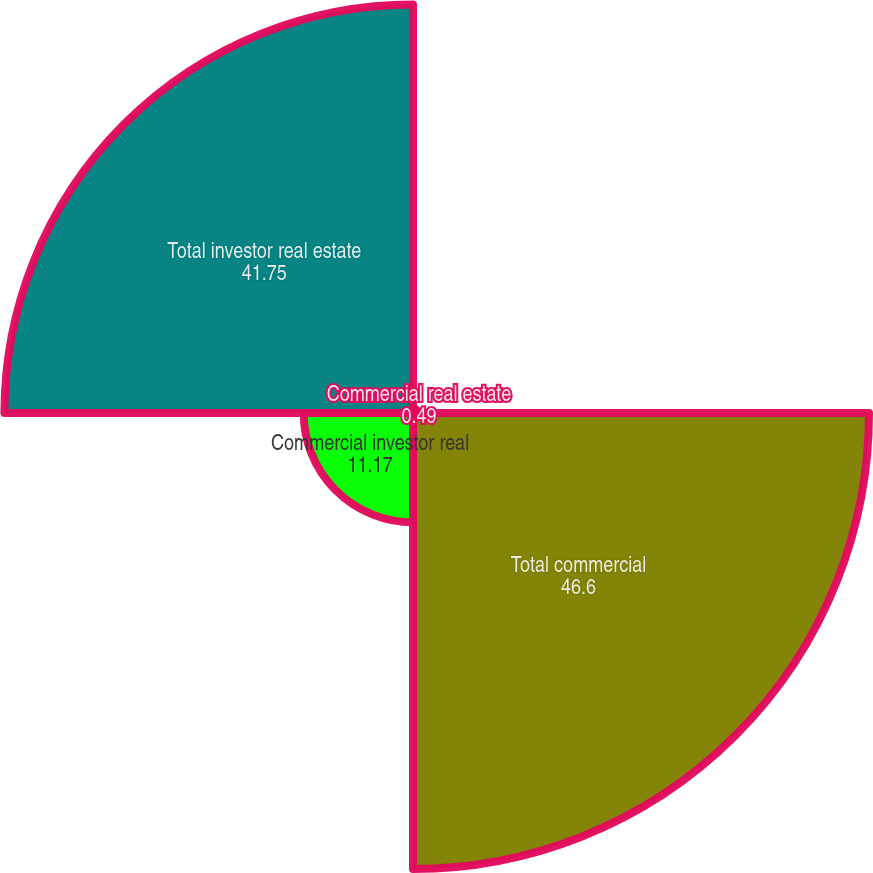Convert chart. <chart><loc_0><loc_0><loc_500><loc_500><pie_chart><fcel>Commercial real estate<fcel>Total commercial<fcel>Commercial investor real<fcel>Total investor real estate<nl><fcel>0.49%<fcel>46.6%<fcel>11.17%<fcel>41.75%<nl></chart> 